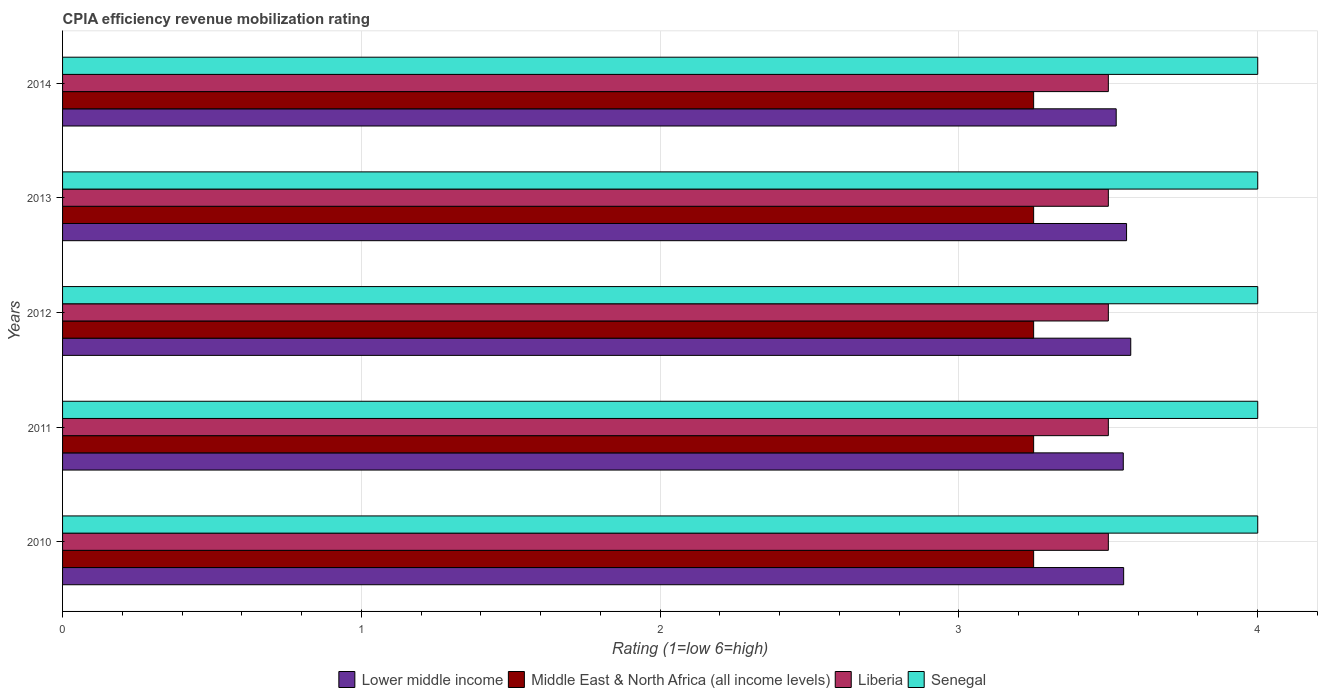How many groups of bars are there?
Make the answer very short. 5. Are the number of bars on each tick of the Y-axis equal?
Ensure brevity in your answer.  Yes. How many bars are there on the 2nd tick from the top?
Make the answer very short. 4. In how many cases, is the number of bars for a given year not equal to the number of legend labels?
Provide a short and direct response. 0. Across all years, what is the maximum CPIA rating in Lower middle income?
Provide a short and direct response. 3.58. In which year was the CPIA rating in Liberia maximum?
Keep it short and to the point. 2010. What is the total CPIA rating in Liberia in the graph?
Your response must be concise. 17.5. What is the difference between the CPIA rating in Lower middle income in 2010 and that in 2012?
Ensure brevity in your answer.  -0.02. What is the difference between the CPIA rating in Lower middle income in 2014 and the CPIA rating in Middle East & North Africa (all income levels) in 2012?
Your answer should be very brief. 0.28. What is the average CPIA rating in Senegal per year?
Your answer should be compact. 4. In the year 2012, what is the difference between the CPIA rating in Senegal and CPIA rating in Liberia?
Your answer should be compact. 0.5. In how many years, is the CPIA rating in Senegal greater than 2.2 ?
Offer a terse response. 5. What is the ratio of the CPIA rating in Liberia in 2010 to that in 2011?
Give a very brief answer. 1. Is the CPIA rating in Lower middle income in 2012 less than that in 2014?
Offer a very short reply. No. Is the difference between the CPIA rating in Senegal in 2011 and 2013 greater than the difference between the CPIA rating in Liberia in 2011 and 2013?
Ensure brevity in your answer.  No. What is the difference between the highest and the second highest CPIA rating in Lower middle income?
Your answer should be compact. 0.01. In how many years, is the CPIA rating in Senegal greater than the average CPIA rating in Senegal taken over all years?
Keep it short and to the point. 0. Is the sum of the CPIA rating in Lower middle income in 2010 and 2011 greater than the maximum CPIA rating in Senegal across all years?
Your answer should be very brief. Yes. What does the 2nd bar from the top in 2010 represents?
Make the answer very short. Liberia. What does the 4th bar from the bottom in 2013 represents?
Offer a very short reply. Senegal. Is it the case that in every year, the sum of the CPIA rating in Middle East & North Africa (all income levels) and CPIA rating in Lower middle income is greater than the CPIA rating in Liberia?
Your answer should be very brief. Yes. How many bars are there?
Offer a terse response. 20. What is the difference between two consecutive major ticks on the X-axis?
Your answer should be compact. 1. Where does the legend appear in the graph?
Provide a short and direct response. Bottom center. How many legend labels are there?
Give a very brief answer. 4. What is the title of the graph?
Your response must be concise. CPIA efficiency revenue mobilization rating. What is the label or title of the X-axis?
Your response must be concise. Rating (1=low 6=high). What is the label or title of the Y-axis?
Provide a short and direct response. Years. What is the Rating (1=low 6=high) of Lower middle income in 2010?
Your answer should be compact. 3.55. What is the Rating (1=low 6=high) in Middle East & North Africa (all income levels) in 2010?
Give a very brief answer. 3.25. What is the Rating (1=low 6=high) in Liberia in 2010?
Ensure brevity in your answer.  3.5. What is the Rating (1=low 6=high) of Senegal in 2010?
Your answer should be very brief. 4. What is the Rating (1=low 6=high) of Lower middle income in 2011?
Your response must be concise. 3.55. What is the Rating (1=low 6=high) of Middle East & North Africa (all income levels) in 2011?
Keep it short and to the point. 3.25. What is the Rating (1=low 6=high) of Senegal in 2011?
Provide a succinct answer. 4. What is the Rating (1=low 6=high) in Lower middle income in 2012?
Make the answer very short. 3.58. What is the Rating (1=low 6=high) of Lower middle income in 2013?
Provide a succinct answer. 3.56. What is the Rating (1=low 6=high) in Senegal in 2013?
Provide a short and direct response. 4. What is the Rating (1=low 6=high) of Lower middle income in 2014?
Give a very brief answer. 3.53. Across all years, what is the maximum Rating (1=low 6=high) of Lower middle income?
Your answer should be compact. 3.58. Across all years, what is the maximum Rating (1=low 6=high) of Middle East & North Africa (all income levels)?
Offer a very short reply. 3.25. Across all years, what is the maximum Rating (1=low 6=high) of Liberia?
Keep it short and to the point. 3.5. Across all years, what is the maximum Rating (1=low 6=high) in Senegal?
Ensure brevity in your answer.  4. Across all years, what is the minimum Rating (1=low 6=high) of Lower middle income?
Your answer should be compact. 3.53. Across all years, what is the minimum Rating (1=low 6=high) in Middle East & North Africa (all income levels)?
Make the answer very short. 3.25. Across all years, what is the minimum Rating (1=low 6=high) in Liberia?
Your answer should be compact. 3.5. What is the total Rating (1=low 6=high) of Lower middle income in the graph?
Offer a terse response. 17.76. What is the total Rating (1=low 6=high) in Middle East & North Africa (all income levels) in the graph?
Keep it short and to the point. 16.25. What is the difference between the Rating (1=low 6=high) of Lower middle income in 2010 and that in 2011?
Give a very brief answer. 0. What is the difference between the Rating (1=low 6=high) in Liberia in 2010 and that in 2011?
Provide a succinct answer. 0. What is the difference between the Rating (1=low 6=high) of Lower middle income in 2010 and that in 2012?
Your response must be concise. -0.02. What is the difference between the Rating (1=low 6=high) in Liberia in 2010 and that in 2012?
Provide a succinct answer. 0. What is the difference between the Rating (1=low 6=high) in Lower middle income in 2010 and that in 2013?
Your answer should be very brief. -0.01. What is the difference between the Rating (1=low 6=high) in Middle East & North Africa (all income levels) in 2010 and that in 2013?
Offer a terse response. 0. What is the difference between the Rating (1=low 6=high) of Liberia in 2010 and that in 2013?
Ensure brevity in your answer.  0. What is the difference between the Rating (1=low 6=high) in Senegal in 2010 and that in 2013?
Your answer should be very brief. 0. What is the difference between the Rating (1=low 6=high) in Lower middle income in 2010 and that in 2014?
Offer a terse response. 0.03. What is the difference between the Rating (1=low 6=high) of Middle East & North Africa (all income levels) in 2010 and that in 2014?
Provide a succinct answer. 0. What is the difference between the Rating (1=low 6=high) in Liberia in 2010 and that in 2014?
Offer a very short reply. 0. What is the difference between the Rating (1=low 6=high) of Lower middle income in 2011 and that in 2012?
Make the answer very short. -0.03. What is the difference between the Rating (1=low 6=high) of Middle East & North Africa (all income levels) in 2011 and that in 2012?
Keep it short and to the point. 0. What is the difference between the Rating (1=low 6=high) of Lower middle income in 2011 and that in 2013?
Provide a short and direct response. -0.01. What is the difference between the Rating (1=low 6=high) of Middle East & North Africa (all income levels) in 2011 and that in 2013?
Keep it short and to the point. 0. What is the difference between the Rating (1=low 6=high) in Liberia in 2011 and that in 2013?
Your answer should be compact. 0. What is the difference between the Rating (1=low 6=high) of Lower middle income in 2011 and that in 2014?
Keep it short and to the point. 0.02. What is the difference between the Rating (1=low 6=high) in Middle East & North Africa (all income levels) in 2011 and that in 2014?
Offer a very short reply. 0. What is the difference between the Rating (1=low 6=high) in Liberia in 2011 and that in 2014?
Make the answer very short. 0. What is the difference between the Rating (1=low 6=high) in Senegal in 2011 and that in 2014?
Give a very brief answer. 0. What is the difference between the Rating (1=low 6=high) in Lower middle income in 2012 and that in 2013?
Give a very brief answer. 0.01. What is the difference between the Rating (1=low 6=high) of Lower middle income in 2012 and that in 2014?
Provide a short and direct response. 0.05. What is the difference between the Rating (1=low 6=high) of Middle East & North Africa (all income levels) in 2012 and that in 2014?
Your response must be concise. 0. What is the difference between the Rating (1=low 6=high) of Liberia in 2012 and that in 2014?
Give a very brief answer. 0. What is the difference between the Rating (1=low 6=high) in Lower middle income in 2013 and that in 2014?
Make the answer very short. 0.03. What is the difference between the Rating (1=low 6=high) in Middle East & North Africa (all income levels) in 2013 and that in 2014?
Provide a succinct answer. 0. What is the difference between the Rating (1=low 6=high) of Liberia in 2013 and that in 2014?
Offer a very short reply. 0. What is the difference between the Rating (1=low 6=high) of Senegal in 2013 and that in 2014?
Your answer should be very brief. 0. What is the difference between the Rating (1=low 6=high) of Lower middle income in 2010 and the Rating (1=low 6=high) of Middle East & North Africa (all income levels) in 2011?
Keep it short and to the point. 0.3. What is the difference between the Rating (1=low 6=high) of Lower middle income in 2010 and the Rating (1=low 6=high) of Liberia in 2011?
Provide a succinct answer. 0.05. What is the difference between the Rating (1=low 6=high) of Lower middle income in 2010 and the Rating (1=low 6=high) of Senegal in 2011?
Your answer should be very brief. -0.45. What is the difference between the Rating (1=low 6=high) of Middle East & North Africa (all income levels) in 2010 and the Rating (1=low 6=high) of Senegal in 2011?
Your answer should be compact. -0.75. What is the difference between the Rating (1=low 6=high) of Lower middle income in 2010 and the Rating (1=low 6=high) of Middle East & North Africa (all income levels) in 2012?
Your answer should be very brief. 0.3. What is the difference between the Rating (1=low 6=high) in Lower middle income in 2010 and the Rating (1=low 6=high) in Liberia in 2012?
Keep it short and to the point. 0.05. What is the difference between the Rating (1=low 6=high) of Lower middle income in 2010 and the Rating (1=low 6=high) of Senegal in 2012?
Give a very brief answer. -0.45. What is the difference between the Rating (1=low 6=high) in Middle East & North Africa (all income levels) in 2010 and the Rating (1=low 6=high) in Liberia in 2012?
Make the answer very short. -0.25. What is the difference between the Rating (1=low 6=high) in Middle East & North Africa (all income levels) in 2010 and the Rating (1=low 6=high) in Senegal in 2012?
Your answer should be compact. -0.75. What is the difference between the Rating (1=low 6=high) of Liberia in 2010 and the Rating (1=low 6=high) of Senegal in 2012?
Ensure brevity in your answer.  -0.5. What is the difference between the Rating (1=low 6=high) in Lower middle income in 2010 and the Rating (1=low 6=high) in Middle East & North Africa (all income levels) in 2013?
Your response must be concise. 0.3. What is the difference between the Rating (1=low 6=high) of Lower middle income in 2010 and the Rating (1=low 6=high) of Liberia in 2013?
Make the answer very short. 0.05. What is the difference between the Rating (1=low 6=high) of Lower middle income in 2010 and the Rating (1=low 6=high) of Senegal in 2013?
Offer a terse response. -0.45. What is the difference between the Rating (1=low 6=high) in Middle East & North Africa (all income levels) in 2010 and the Rating (1=low 6=high) in Senegal in 2013?
Your answer should be compact. -0.75. What is the difference between the Rating (1=low 6=high) in Lower middle income in 2010 and the Rating (1=low 6=high) in Middle East & North Africa (all income levels) in 2014?
Your response must be concise. 0.3. What is the difference between the Rating (1=low 6=high) in Lower middle income in 2010 and the Rating (1=low 6=high) in Liberia in 2014?
Your answer should be very brief. 0.05. What is the difference between the Rating (1=low 6=high) in Lower middle income in 2010 and the Rating (1=low 6=high) in Senegal in 2014?
Your answer should be compact. -0.45. What is the difference between the Rating (1=low 6=high) in Middle East & North Africa (all income levels) in 2010 and the Rating (1=low 6=high) in Senegal in 2014?
Your answer should be compact. -0.75. What is the difference between the Rating (1=low 6=high) of Lower middle income in 2011 and the Rating (1=low 6=high) of Middle East & North Africa (all income levels) in 2012?
Your answer should be very brief. 0.3. What is the difference between the Rating (1=low 6=high) of Lower middle income in 2011 and the Rating (1=low 6=high) of Liberia in 2012?
Give a very brief answer. 0.05. What is the difference between the Rating (1=low 6=high) in Lower middle income in 2011 and the Rating (1=low 6=high) in Senegal in 2012?
Offer a very short reply. -0.45. What is the difference between the Rating (1=low 6=high) of Middle East & North Africa (all income levels) in 2011 and the Rating (1=low 6=high) of Senegal in 2012?
Provide a succinct answer. -0.75. What is the difference between the Rating (1=low 6=high) in Liberia in 2011 and the Rating (1=low 6=high) in Senegal in 2012?
Your response must be concise. -0.5. What is the difference between the Rating (1=low 6=high) in Lower middle income in 2011 and the Rating (1=low 6=high) in Middle East & North Africa (all income levels) in 2013?
Offer a terse response. 0.3. What is the difference between the Rating (1=low 6=high) in Lower middle income in 2011 and the Rating (1=low 6=high) in Liberia in 2013?
Offer a very short reply. 0.05. What is the difference between the Rating (1=low 6=high) in Lower middle income in 2011 and the Rating (1=low 6=high) in Senegal in 2013?
Your response must be concise. -0.45. What is the difference between the Rating (1=low 6=high) in Middle East & North Africa (all income levels) in 2011 and the Rating (1=low 6=high) in Senegal in 2013?
Your answer should be very brief. -0.75. What is the difference between the Rating (1=low 6=high) of Lower middle income in 2011 and the Rating (1=low 6=high) of Liberia in 2014?
Provide a short and direct response. 0.05. What is the difference between the Rating (1=low 6=high) of Lower middle income in 2011 and the Rating (1=low 6=high) of Senegal in 2014?
Your answer should be compact. -0.45. What is the difference between the Rating (1=low 6=high) in Middle East & North Africa (all income levels) in 2011 and the Rating (1=low 6=high) in Senegal in 2014?
Keep it short and to the point. -0.75. What is the difference between the Rating (1=low 6=high) in Lower middle income in 2012 and the Rating (1=low 6=high) in Middle East & North Africa (all income levels) in 2013?
Give a very brief answer. 0.33. What is the difference between the Rating (1=low 6=high) of Lower middle income in 2012 and the Rating (1=low 6=high) of Liberia in 2013?
Offer a terse response. 0.07. What is the difference between the Rating (1=low 6=high) of Lower middle income in 2012 and the Rating (1=low 6=high) of Senegal in 2013?
Provide a succinct answer. -0.42. What is the difference between the Rating (1=low 6=high) in Middle East & North Africa (all income levels) in 2012 and the Rating (1=low 6=high) in Liberia in 2013?
Provide a succinct answer. -0.25. What is the difference between the Rating (1=low 6=high) in Middle East & North Africa (all income levels) in 2012 and the Rating (1=low 6=high) in Senegal in 2013?
Keep it short and to the point. -0.75. What is the difference between the Rating (1=low 6=high) of Lower middle income in 2012 and the Rating (1=low 6=high) of Middle East & North Africa (all income levels) in 2014?
Your answer should be very brief. 0.33. What is the difference between the Rating (1=low 6=high) in Lower middle income in 2012 and the Rating (1=low 6=high) in Liberia in 2014?
Offer a terse response. 0.07. What is the difference between the Rating (1=low 6=high) of Lower middle income in 2012 and the Rating (1=low 6=high) of Senegal in 2014?
Keep it short and to the point. -0.42. What is the difference between the Rating (1=low 6=high) in Middle East & North Africa (all income levels) in 2012 and the Rating (1=low 6=high) in Liberia in 2014?
Provide a short and direct response. -0.25. What is the difference between the Rating (1=low 6=high) of Middle East & North Africa (all income levels) in 2012 and the Rating (1=low 6=high) of Senegal in 2014?
Your response must be concise. -0.75. What is the difference between the Rating (1=low 6=high) in Liberia in 2012 and the Rating (1=low 6=high) in Senegal in 2014?
Keep it short and to the point. -0.5. What is the difference between the Rating (1=low 6=high) of Lower middle income in 2013 and the Rating (1=low 6=high) of Middle East & North Africa (all income levels) in 2014?
Give a very brief answer. 0.31. What is the difference between the Rating (1=low 6=high) of Lower middle income in 2013 and the Rating (1=low 6=high) of Liberia in 2014?
Offer a terse response. 0.06. What is the difference between the Rating (1=low 6=high) of Lower middle income in 2013 and the Rating (1=low 6=high) of Senegal in 2014?
Offer a terse response. -0.44. What is the difference between the Rating (1=low 6=high) of Middle East & North Africa (all income levels) in 2013 and the Rating (1=low 6=high) of Senegal in 2014?
Make the answer very short. -0.75. What is the average Rating (1=low 6=high) in Lower middle income per year?
Provide a succinct answer. 3.55. What is the average Rating (1=low 6=high) in Senegal per year?
Your answer should be compact. 4. In the year 2010, what is the difference between the Rating (1=low 6=high) in Lower middle income and Rating (1=low 6=high) in Middle East & North Africa (all income levels)?
Offer a very short reply. 0.3. In the year 2010, what is the difference between the Rating (1=low 6=high) of Lower middle income and Rating (1=low 6=high) of Liberia?
Your answer should be very brief. 0.05. In the year 2010, what is the difference between the Rating (1=low 6=high) in Lower middle income and Rating (1=low 6=high) in Senegal?
Give a very brief answer. -0.45. In the year 2010, what is the difference between the Rating (1=low 6=high) in Middle East & North Africa (all income levels) and Rating (1=low 6=high) in Liberia?
Keep it short and to the point. -0.25. In the year 2010, what is the difference between the Rating (1=low 6=high) in Middle East & North Africa (all income levels) and Rating (1=low 6=high) in Senegal?
Offer a very short reply. -0.75. In the year 2010, what is the difference between the Rating (1=low 6=high) in Liberia and Rating (1=low 6=high) in Senegal?
Provide a short and direct response. -0.5. In the year 2011, what is the difference between the Rating (1=low 6=high) of Lower middle income and Rating (1=low 6=high) of Middle East & North Africa (all income levels)?
Offer a terse response. 0.3. In the year 2011, what is the difference between the Rating (1=low 6=high) of Lower middle income and Rating (1=low 6=high) of Liberia?
Ensure brevity in your answer.  0.05. In the year 2011, what is the difference between the Rating (1=low 6=high) of Lower middle income and Rating (1=low 6=high) of Senegal?
Give a very brief answer. -0.45. In the year 2011, what is the difference between the Rating (1=low 6=high) of Middle East & North Africa (all income levels) and Rating (1=low 6=high) of Liberia?
Your answer should be very brief. -0.25. In the year 2011, what is the difference between the Rating (1=low 6=high) of Middle East & North Africa (all income levels) and Rating (1=low 6=high) of Senegal?
Your answer should be compact. -0.75. In the year 2011, what is the difference between the Rating (1=low 6=high) of Liberia and Rating (1=low 6=high) of Senegal?
Make the answer very short. -0.5. In the year 2012, what is the difference between the Rating (1=low 6=high) of Lower middle income and Rating (1=low 6=high) of Middle East & North Africa (all income levels)?
Provide a short and direct response. 0.33. In the year 2012, what is the difference between the Rating (1=low 6=high) of Lower middle income and Rating (1=low 6=high) of Liberia?
Your response must be concise. 0.07. In the year 2012, what is the difference between the Rating (1=low 6=high) of Lower middle income and Rating (1=low 6=high) of Senegal?
Offer a very short reply. -0.42. In the year 2012, what is the difference between the Rating (1=low 6=high) of Middle East & North Africa (all income levels) and Rating (1=low 6=high) of Senegal?
Give a very brief answer. -0.75. In the year 2012, what is the difference between the Rating (1=low 6=high) in Liberia and Rating (1=low 6=high) in Senegal?
Make the answer very short. -0.5. In the year 2013, what is the difference between the Rating (1=low 6=high) in Lower middle income and Rating (1=low 6=high) in Middle East & North Africa (all income levels)?
Make the answer very short. 0.31. In the year 2013, what is the difference between the Rating (1=low 6=high) in Lower middle income and Rating (1=low 6=high) in Liberia?
Your answer should be compact. 0.06. In the year 2013, what is the difference between the Rating (1=low 6=high) of Lower middle income and Rating (1=low 6=high) of Senegal?
Make the answer very short. -0.44. In the year 2013, what is the difference between the Rating (1=low 6=high) in Middle East & North Africa (all income levels) and Rating (1=low 6=high) in Senegal?
Your response must be concise. -0.75. In the year 2014, what is the difference between the Rating (1=low 6=high) in Lower middle income and Rating (1=low 6=high) in Middle East & North Africa (all income levels)?
Your answer should be very brief. 0.28. In the year 2014, what is the difference between the Rating (1=low 6=high) in Lower middle income and Rating (1=low 6=high) in Liberia?
Give a very brief answer. 0.03. In the year 2014, what is the difference between the Rating (1=low 6=high) of Lower middle income and Rating (1=low 6=high) of Senegal?
Ensure brevity in your answer.  -0.47. In the year 2014, what is the difference between the Rating (1=low 6=high) in Middle East & North Africa (all income levels) and Rating (1=low 6=high) in Liberia?
Your answer should be compact. -0.25. In the year 2014, what is the difference between the Rating (1=low 6=high) of Middle East & North Africa (all income levels) and Rating (1=low 6=high) of Senegal?
Provide a succinct answer. -0.75. What is the ratio of the Rating (1=low 6=high) of Middle East & North Africa (all income levels) in 2010 to that in 2011?
Your answer should be compact. 1. What is the ratio of the Rating (1=low 6=high) in Middle East & North Africa (all income levels) in 2010 to that in 2012?
Keep it short and to the point. 1. What is the ratio of the Rating (1=low 6=high) in Senegal in 2010 to that in 2012?
Offer a terse response. 1. What is the ratio of the Rating (1=low 6=high) in Middle East & North Africa (all income levels) in 2010 to that in 2013?
Give a very brief answer. 1. What is the ratio of the Rating (1=low 6=high) of Liberia in 2010 to that in 2013?
Offer a terse response. 1. What is the ratio of the Rating (1=low 6=high) of Senegal in 2010 to that in 2013?
Your answer should be very brief. 1. What is the ratio of the Rating (1=low 6=high) in Lower middle income in 2010 to that in 2014?
Your response must be concise. 1.01. What is the ratio of the Rating (1=low 6=high) of Liberia in 2010 to that in 2014?
Your response must be concise. 1. What is the ratio of the Rating (1=low 6=high) of Middle East & North Africa (all income levels) in 2011 to that in 2013?
Make the answer very short. 1. What is the ratio of the Rating (1=low 6=high) of Senegal in 2011 to that in 2014?
Offer a very short reply. 1. What is the ratio of the Rating (1=low 6=high) in Middle East & North Africa (all income levels) in 2012 to that in 2013?
Offer a very short reply. 1. What is the ratio of the Rating (1=low 6=high) in Senegal in 2012 to that in 2013?
Provide a short and direct response. 1. What is the ratio of the Rating (1=low 6=high) of Lower middle income in 2012 to that in 2014?
Make the answer very short. 1.01. What is the ratio of the Rating (1=low 6=high) in Middle East & North Africa (all income levels) in 2012 to that in 2014?
Provide a succinct answer. 1. What is the ratio of the Rating (1=low 6=high) of Lower middle income in 2013 to that in 2014?
Offer a terse response. 1.01. What is the ratio of the Rating (1=low 6=high) of Middle East & North Africa (all income levels) in 2013 to that in 2014?
Your answer should be compact. 1. What is the difference between the highest and the second highest Rating (1=low 6=high) of Lower middle income?
Make the answer very short. 0.01. What is the difference between the highest and the second highest Rating (1=low 6=high) of Middle East & North Africa (all income levels)?
Provide a short and direct response. 0. What is the difference between the highest and the second highest Rating (1=low 6=high) in Liberia?
Your response must be concise. 0. What is the difference between the highest and the second highest Rating (1=low 6=high) of Senegal?
Ensure brevity in your answer.  0. What is the difference between the highest and the lowest Rating (1=low 6=high) in Lower middle income?
Offer a terse response. 0.05. What is the difference between the highest and the lowest Rating (1=low 6=high) in Senegal?
Provide a short and direct response. 0. 